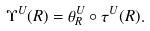Convert formula to latex. <formula><loc_0><loc_0><loc_500><loc_500>\Upsilon ^ { U } ( R ) = \theta _ { R } ^ { U } \circ \tau ^ { U } ( R ) .</formula> 